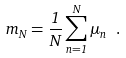Convert formula to latex. <formula><loc_0><loc_0><loc_500><loc_500>m _ { N } = { \frac { 1 } { N } } \sum _ { n = 1 } ^ { N } \mu _ { n } \ .</formula> 